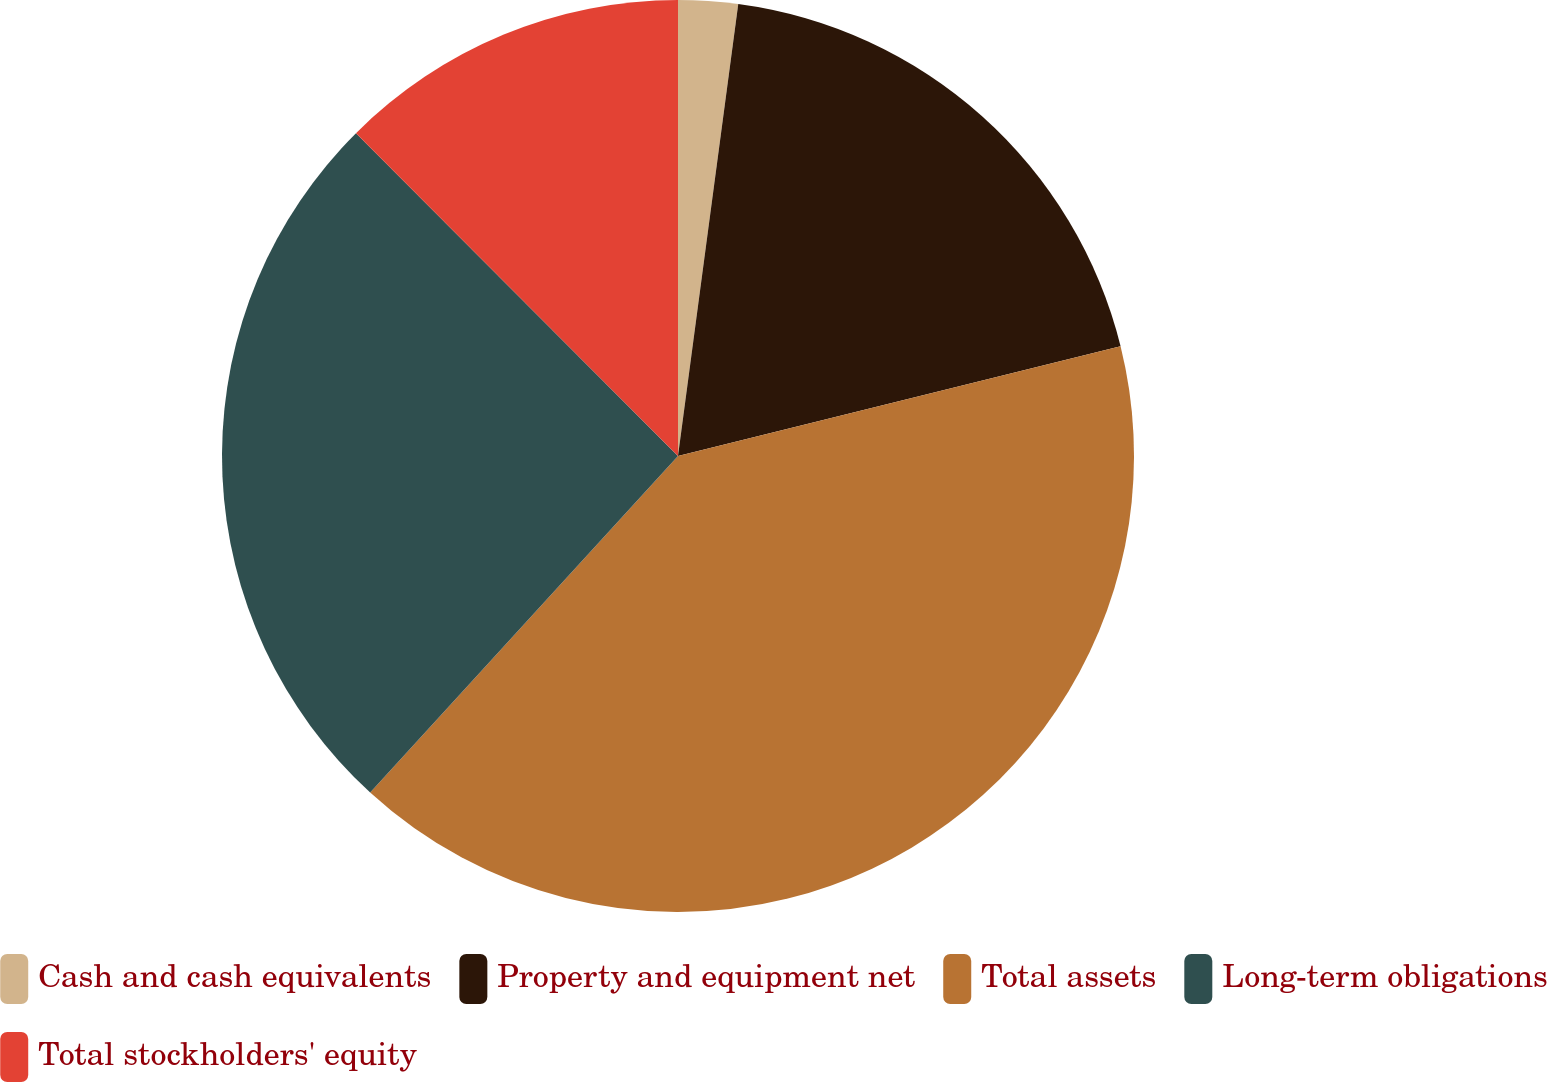<chart> <loc_0><loc_0><loc_500><loc_500><pie_chart><fcel>Cash and cash equivalents<fcel>Property and equipment net<fcel>Total assets<fcel>Long-term obligations<fcel>Total stockholders' equity<nl><fcel>2.11%<fcel>19.02%<fcel>40.67%<fcel>25.73%<fcel>12.48%<nl></chart> 